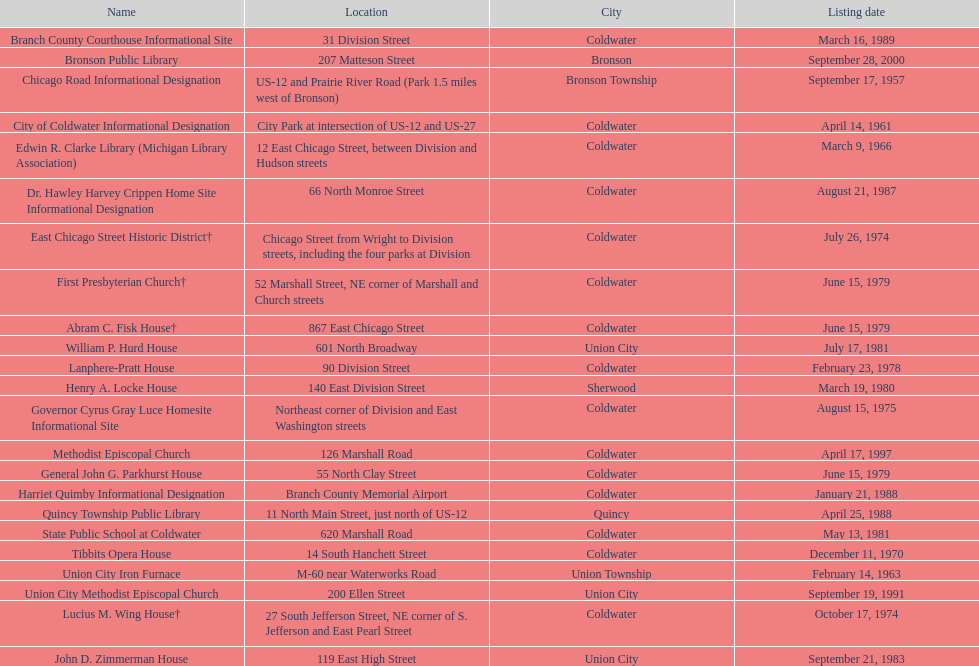Was the state public school or the edwin r. clarke library mentioned earlier in the list? Edwin R. Clarke Library. 